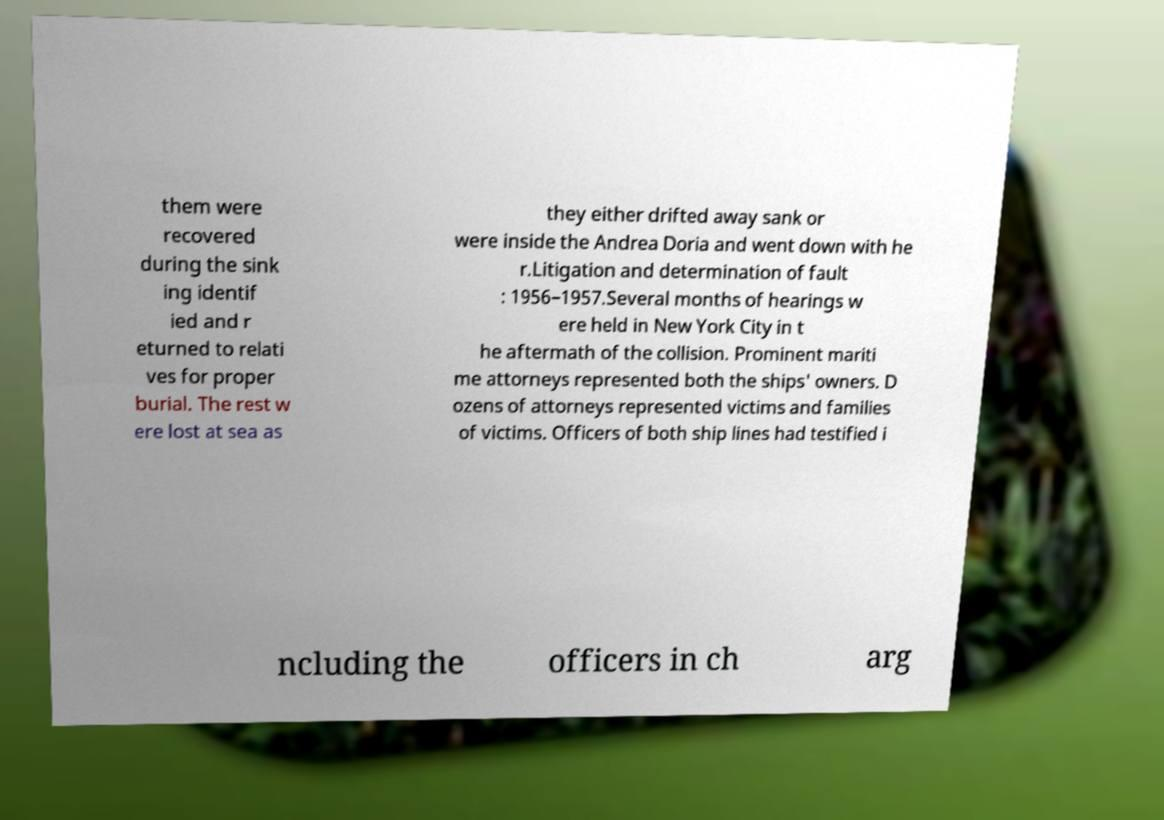Can you accurately transcribe the text from the provided image for me? them were recovered during the sink ing identif ied and r eturned to relati ves for proper burial. The rest w ere lost at sea as they either drifted away sank or were inside the Andrea Doria and went down with he r.Litigation and determination of fault : 1956–1957.Several months of hearings w ere held in New York City in t he aftermath of the collision. Prominent mariti me attorneys represented both the ships' owners. D ozens of attorneys represented victims and families of victims. Officers of both ship lines had testified i ncluding the officers in ch arg 